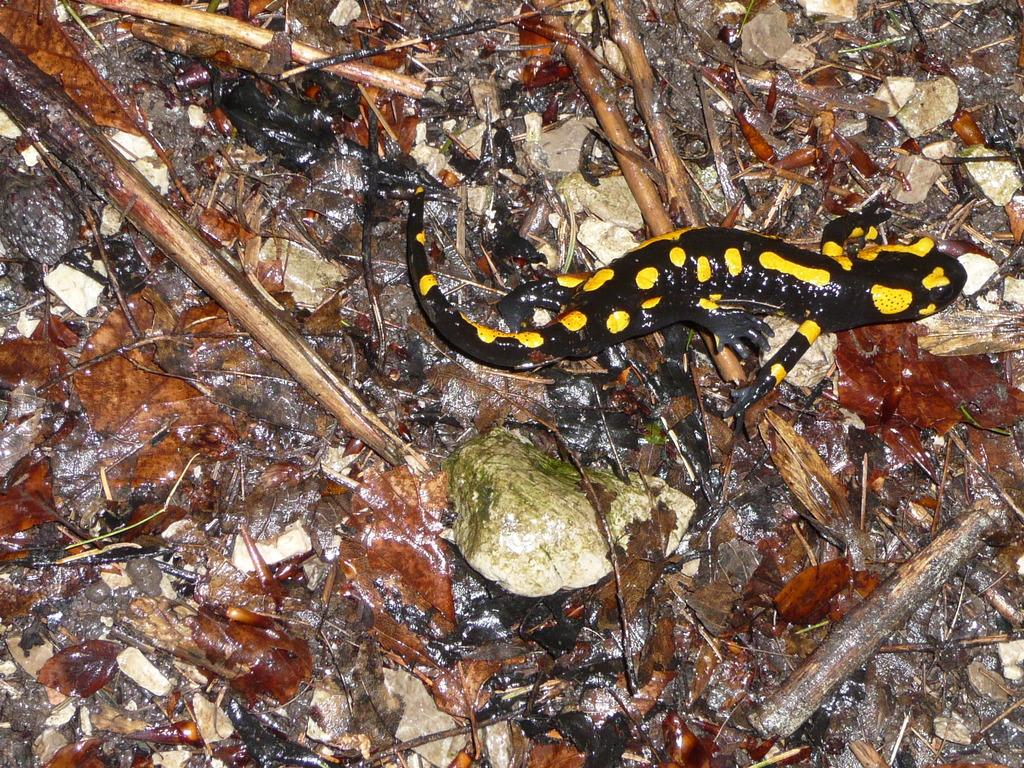What type of animal is in the image? There is a lizard in the image. What colors can be seen on the lizard? The lizard has a black and yellow color combination. Where is the lizard located in the image? The lizard is on the ground. What other objects can be seen on the ground in the image? Dry leaves, sticks, and stones are present on the ground. Can you see a snail using an umbrella in the image? There is no snail or umbrella present in the image. What type of berry can be seen growing on the lizard in the image? There are no berries present on the lizard or in the image. 